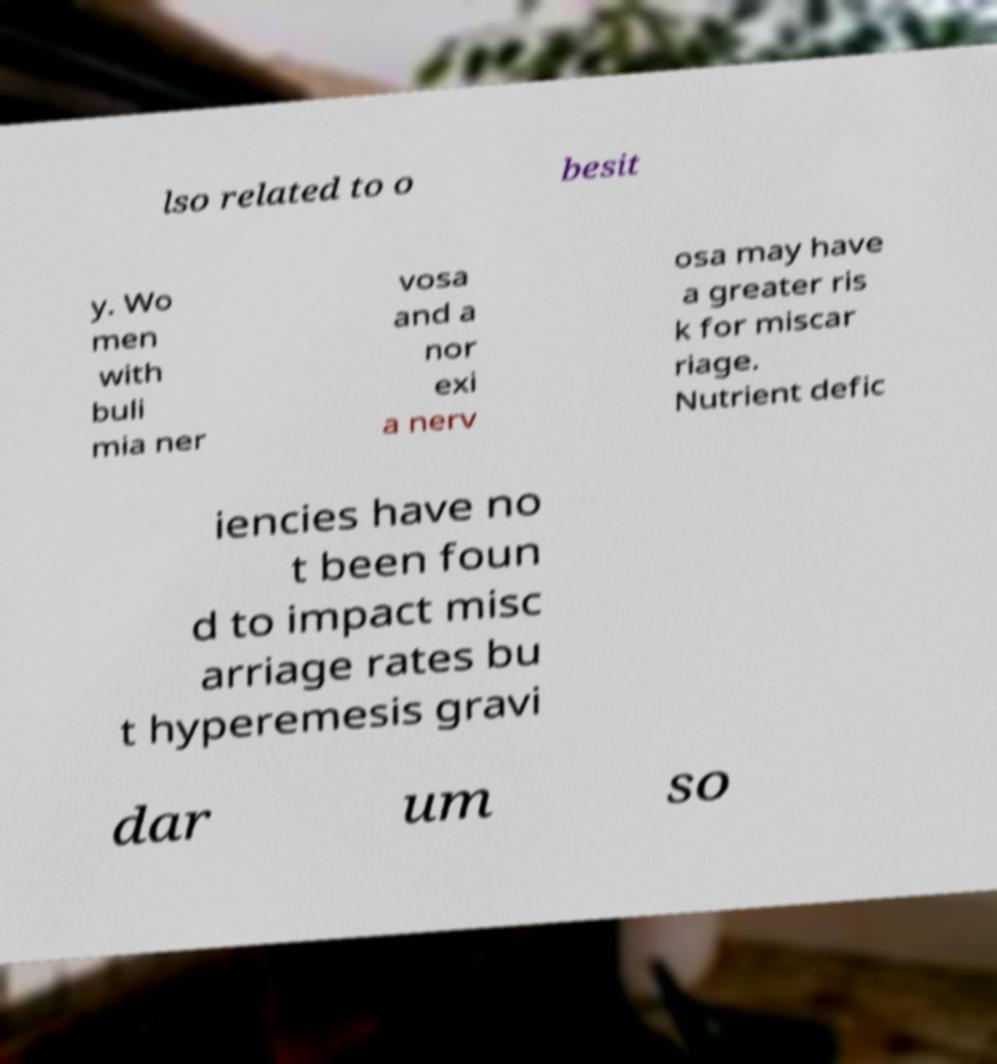Please read and relay the text visible in this image. What does it say? lso related to o besit y. Wo men with buli mia ner vosa and a nor exi a nerv osa may have a greater ris k for miscar riage. Nutrient defic iencies have no t been foun d to impact misc arriage rates bu t hyperemesis gravi dar um so 